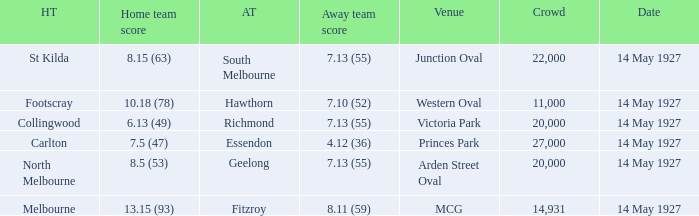Would you be able to parse every entry in this table? {'header': ['HT', 'Home team score', 'AT', 'Away team score', 'Venue', 'Crowd', 'Date'], 'rows': [['St Kilda', '8.15 (63)', 'South Melbourne', '7.13 (55)', 'Junction Oval', '22,000', '14 May 1927'], ['Footscray', '10.18 (78)', 'Hawthorn', '7.10 (52)', 'Western Oval', '11,000', '14 May 1927'], ['Collingwood', '6.13 (49)', 'Richmond', '7.13 (55)', 'Victoria Park', '20,000', '14 May 1927'], ['Carlton', '7.5 (47)', 'Essendon', '4.12 (36)', 'Princes Park', '27,000', '14 May 1927'], ['North Melbourne', '8.5 (53)', 'Geelong', '7.13 (55)', 'Arden Street Oval', '20,000', '14 May 1927'], ['Melbourne', '13.15 (93)', 'Fitzroy', '8.11 (59)', 'MCG', '14,931', '14 May 1927']]} Which away team had a score of 4.12 (36)? Essendon. 